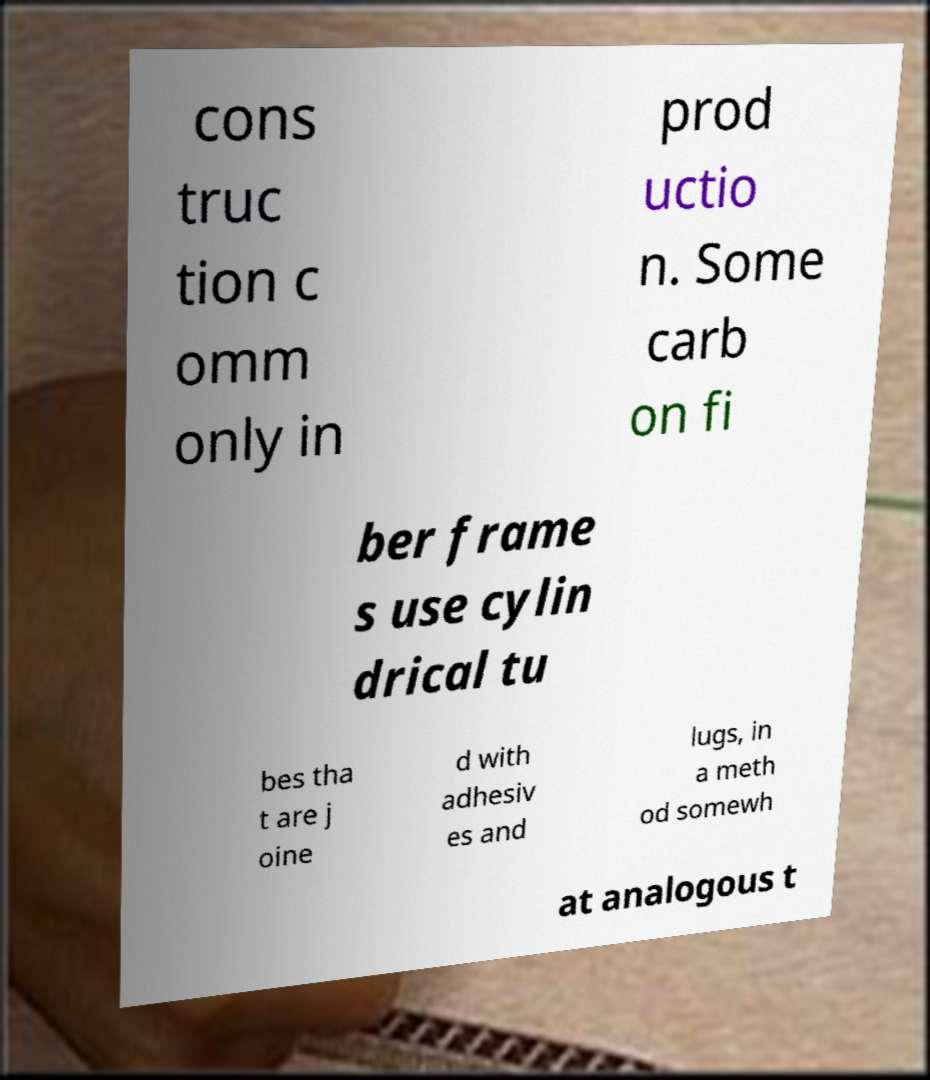Could you assist in decoding the text presented in this image and type it out clearly? cons truc tion c omm only in prod uctio n. Some carb on fi ber frame s use cylin drical tu bes tha t are j oine d with adhesiv es and lugs, in a meth od somewh at analogous t 